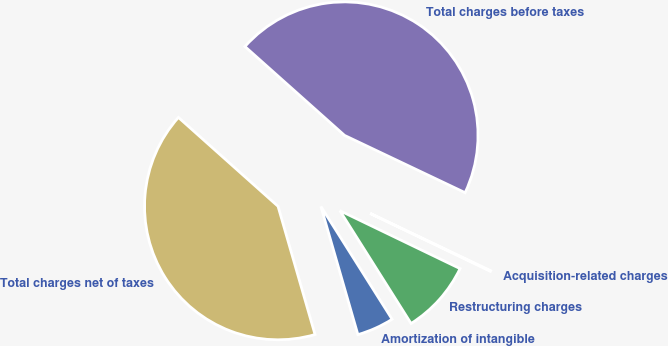Convert chart to OTSL. <chart><loc_0><loc_0><loc_500><loc_500><pie_chart><fcel>Amortization of intangible<fcel>Restructuring charges<fcel>Acquisition-related charges<fcel>Total charges before taxes<fcel>Total charges net of taxes<nl><fcel>4.49%<fcel>8.89%<fcel>0.09%<fcel>45.47%<fcel>41.07%<nl></chart> 